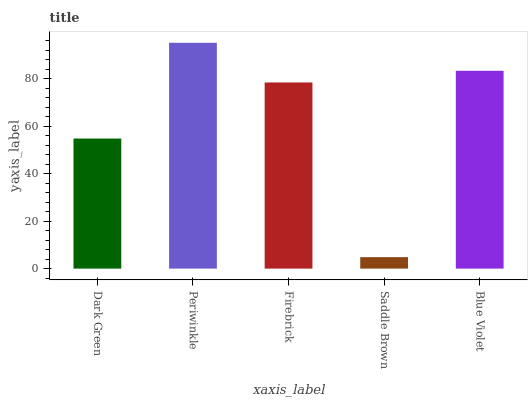Is Firebrick the minimum?
Answer yes or no. No. Is Firebrick the maximum?
Answer yes or no. No. Is Periwinkle greater than Firebrick?
Answer yes or no. Yes. Is Firebrick less than Periwinkle?
Answer yes or no. Yes. Is Firebrick greater than Periwinkle?
Answer yes or no. No. Is Periwinkle less than Firebrick?
Answer yes or no. No. Is Firebrick the high median?
Answer yes or no. Yes. Is Firebrick the low median?
Answer yes or no. Yes. Is Periwinkle the high median?
Answer yes or no. No. Is Periwinkle the low median?
Answer yes or no. No. 